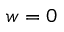<formula> <loc_0><loc_0><loc_500><loc_500>w = 0</formula> 